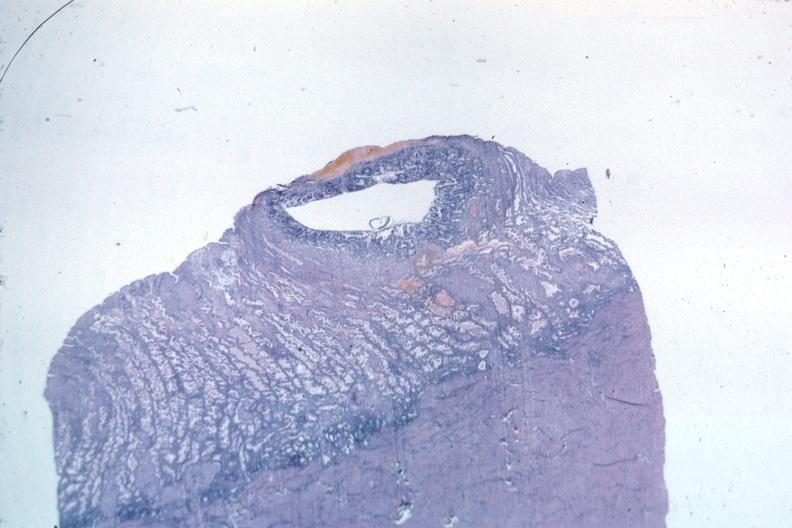s female reproductive present?
Answer the question using a single word or phrase. Yes 